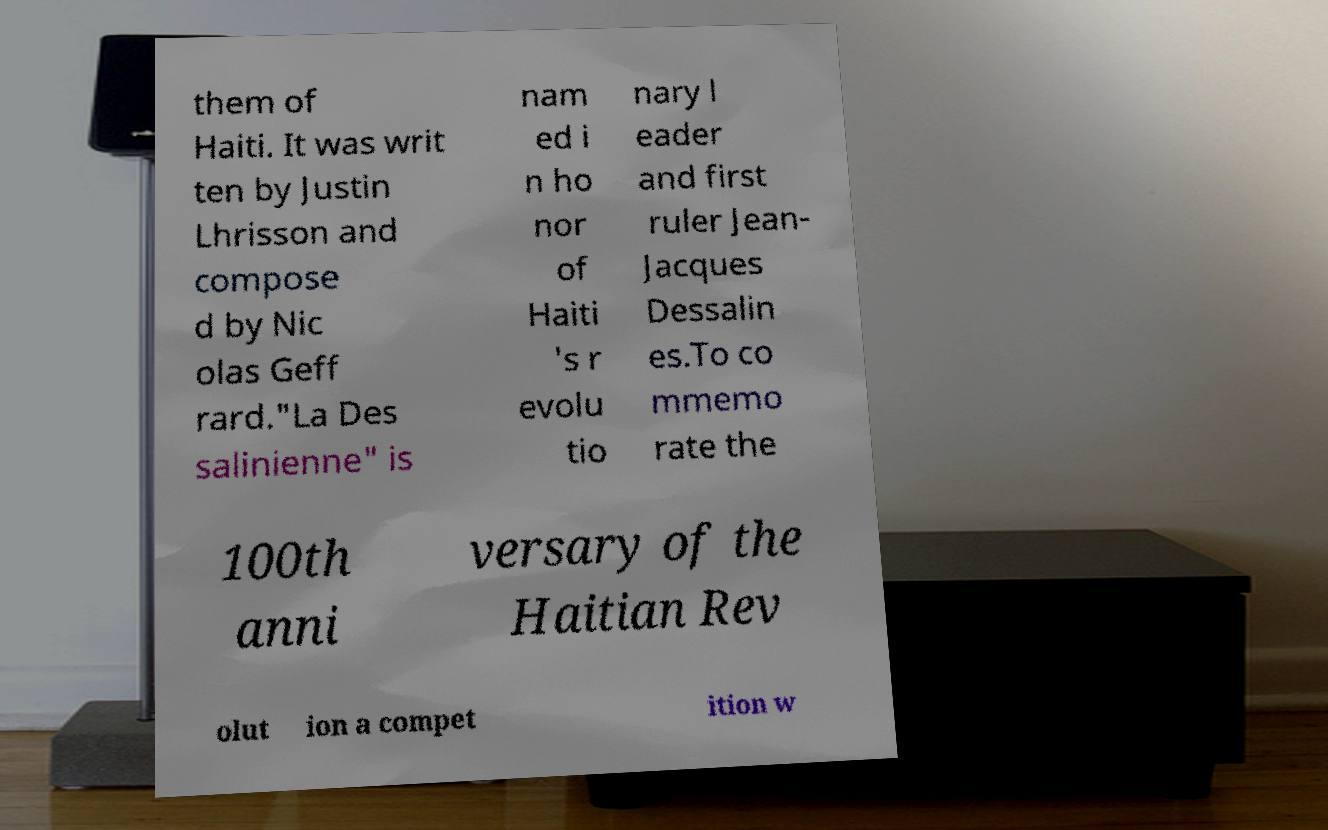Can you accurately transcribe the text from the provided image for me? them of Haiti. It was writ ten by Justin Lhrisson and compose d by Nic olas Geff rard."La Des salinienne" is nam ed i n ho nor of Haiti 's r evolu tio nary l eader and first ruler Jean- Jacques Dessalin es.To co mmemo rate the 100th anni versary of the Haitian Rev olut ion a compet ition w 